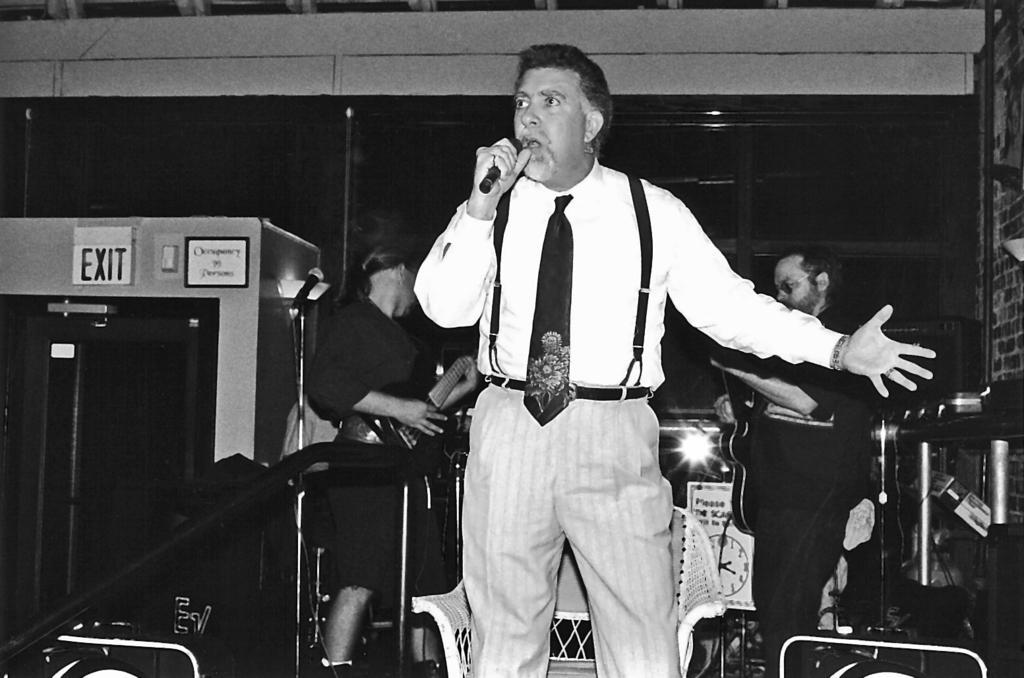How would you summarize this image in a sentence or two? In this image we can see a person holding a microphone. And there are other persons playing musical instruments. We can see the exit board attached to the wall and there are stands, chair and a few objects. 